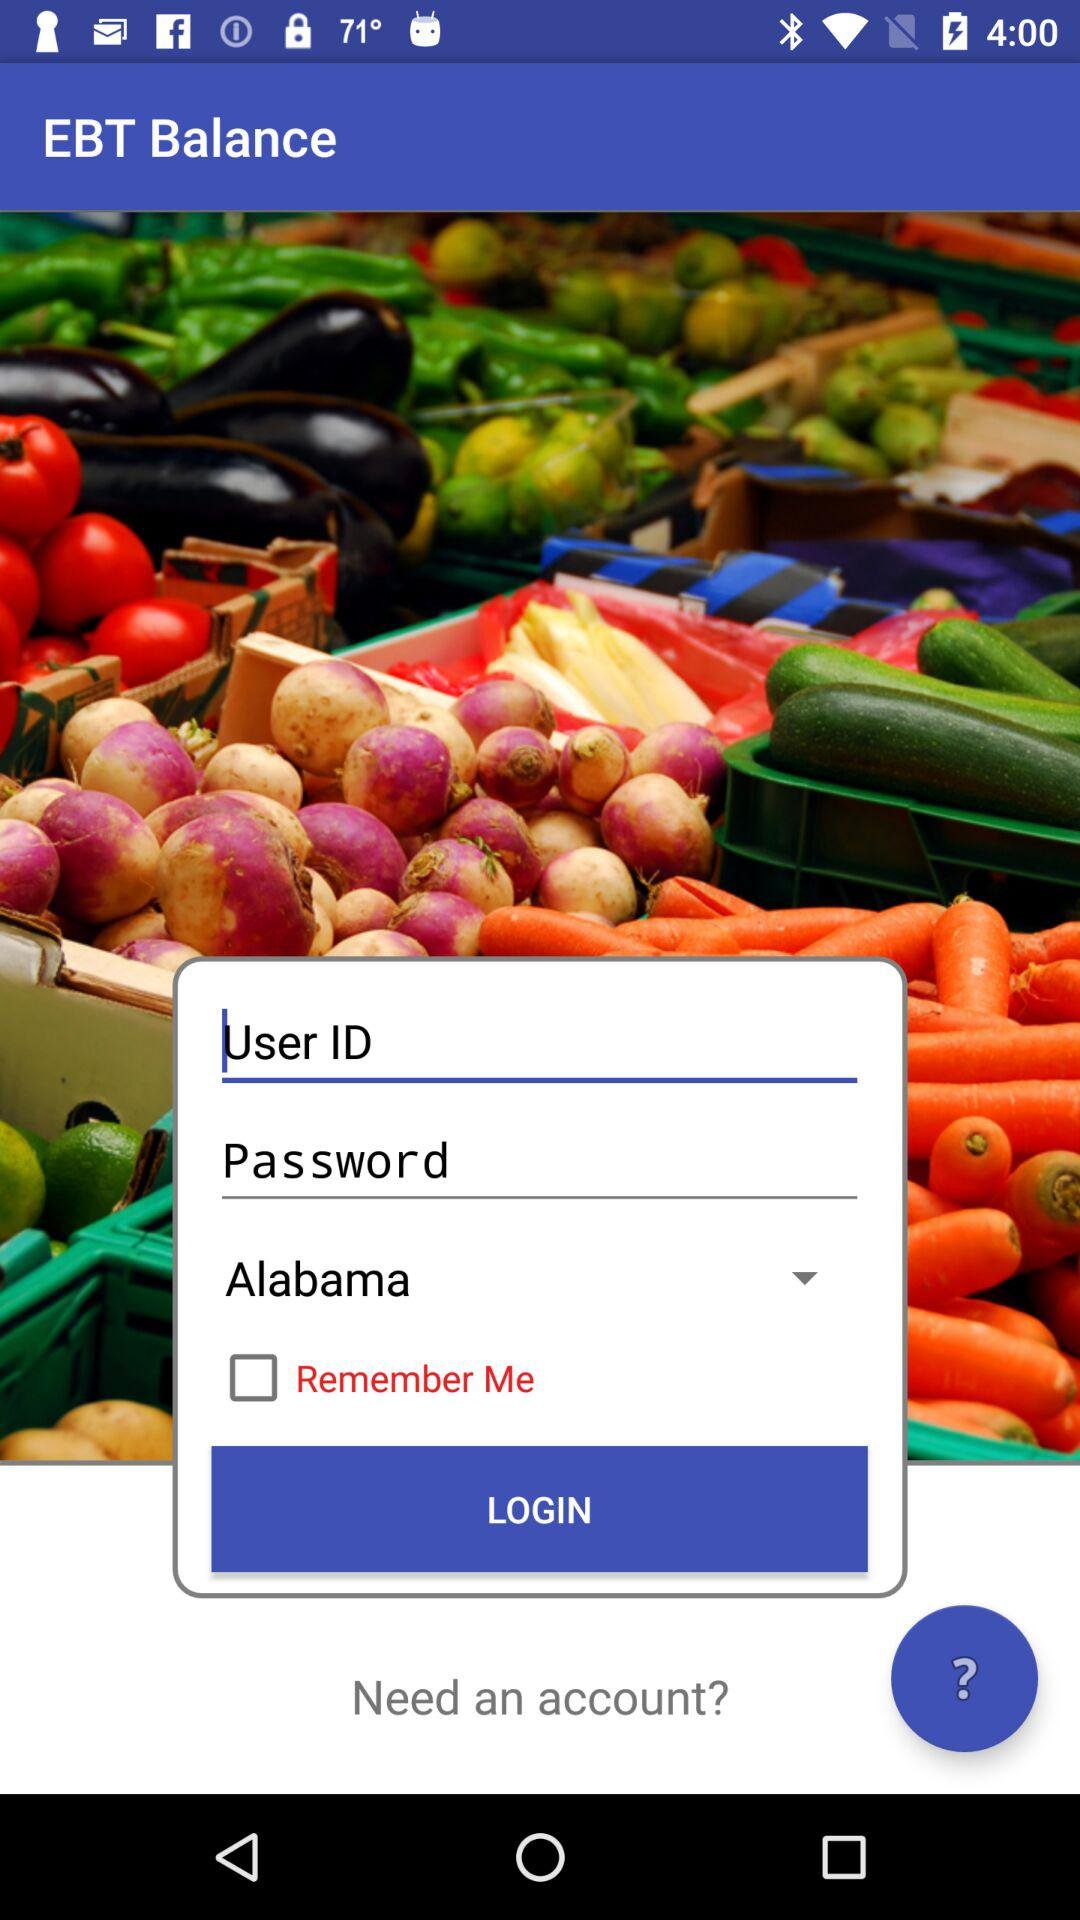What is the name of the app? The name of the app is "EBT Balance". 